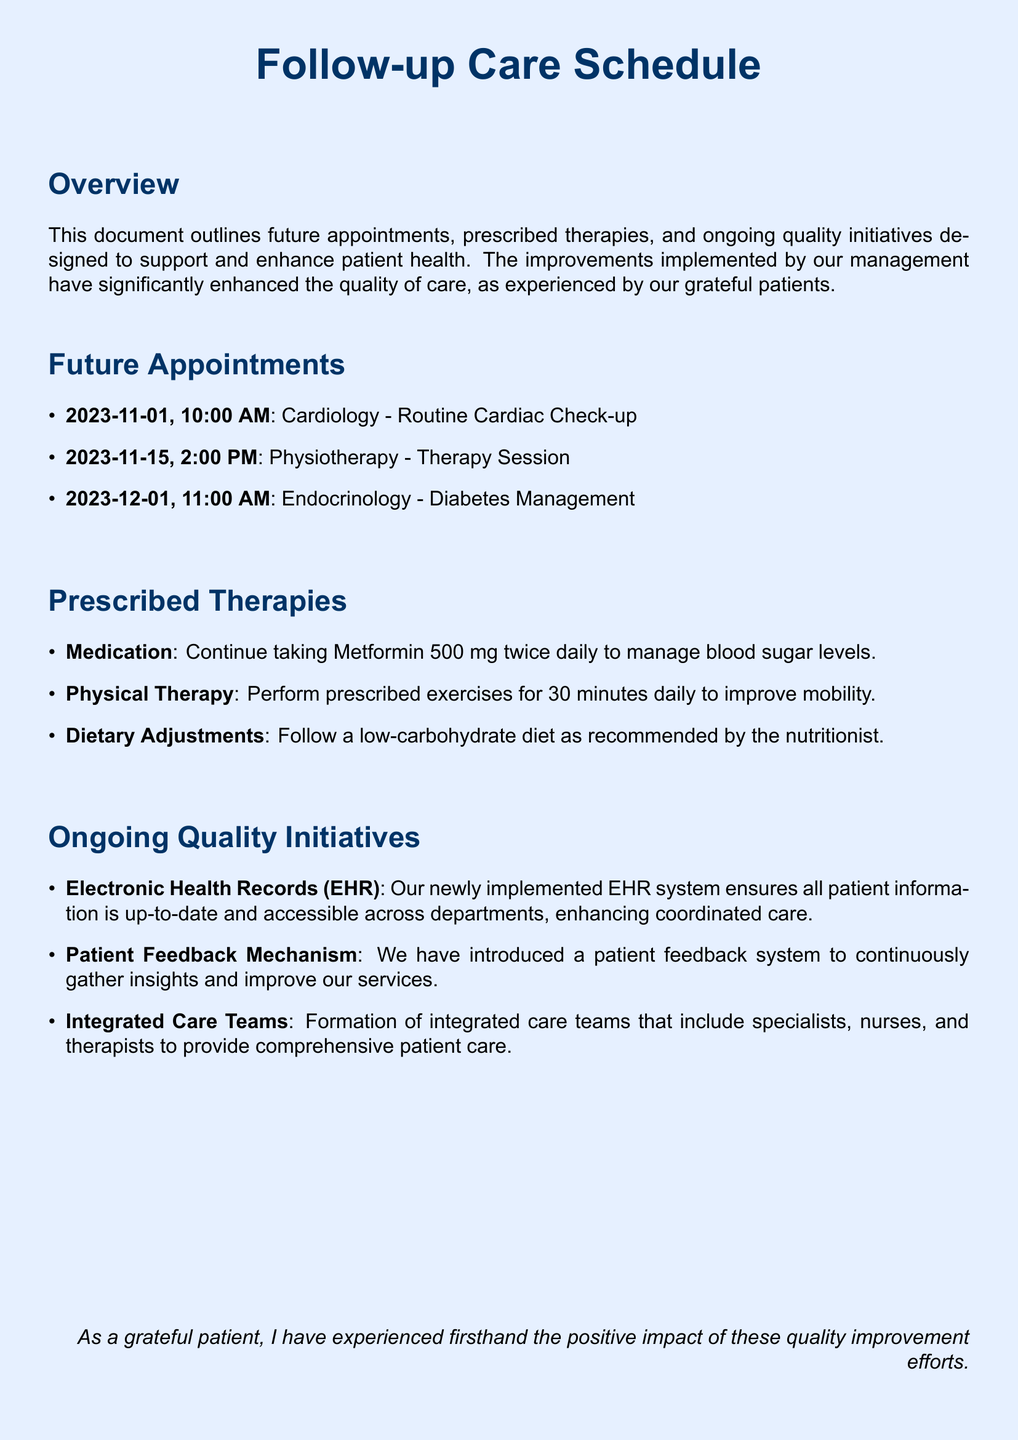What is the first appointment date? The first appointment listed in the document is for cardiology on November 1, 2023.
Answer: November 1, 2023 How many therapy sessions are scheduled? The document lists one physiotherapy therapy session scheduled for November 15, 2023.
Answer: One What medication is prescribed twice daily? The document specifies that Metformin 500 mg is prescribed and that it should be taken twice daily.
Answer: Metformin 500 mg What department is involved in diabetes management? The endocrinology department is scheduled for a meeting regarding diabetes management on December 1, 2023.
Answer: Endocrinology What quality initiative focuses on patient information? The document mentions the newly implemented Electronic Health Records (EHR) system as a key quality initiative focused on patient information management.
Answer: Electronic Health Records (EHR) How often should prescribed exercises be performed? According to the prescribed therapies, the patient is advised to perform exercises for 30 minutes daily.
Answer: Daily What is the purpose of the patient feedback mechanism? The document states that the patient feedback mechanism is introduced to continuously gather insights and improve the services provided.
Answer: Improve services Who forms the integrated care teams? The document mentions that integrated care teams consist of specialists, nurses, and therapists.
Answer: Specialists, nurses, and therapists 